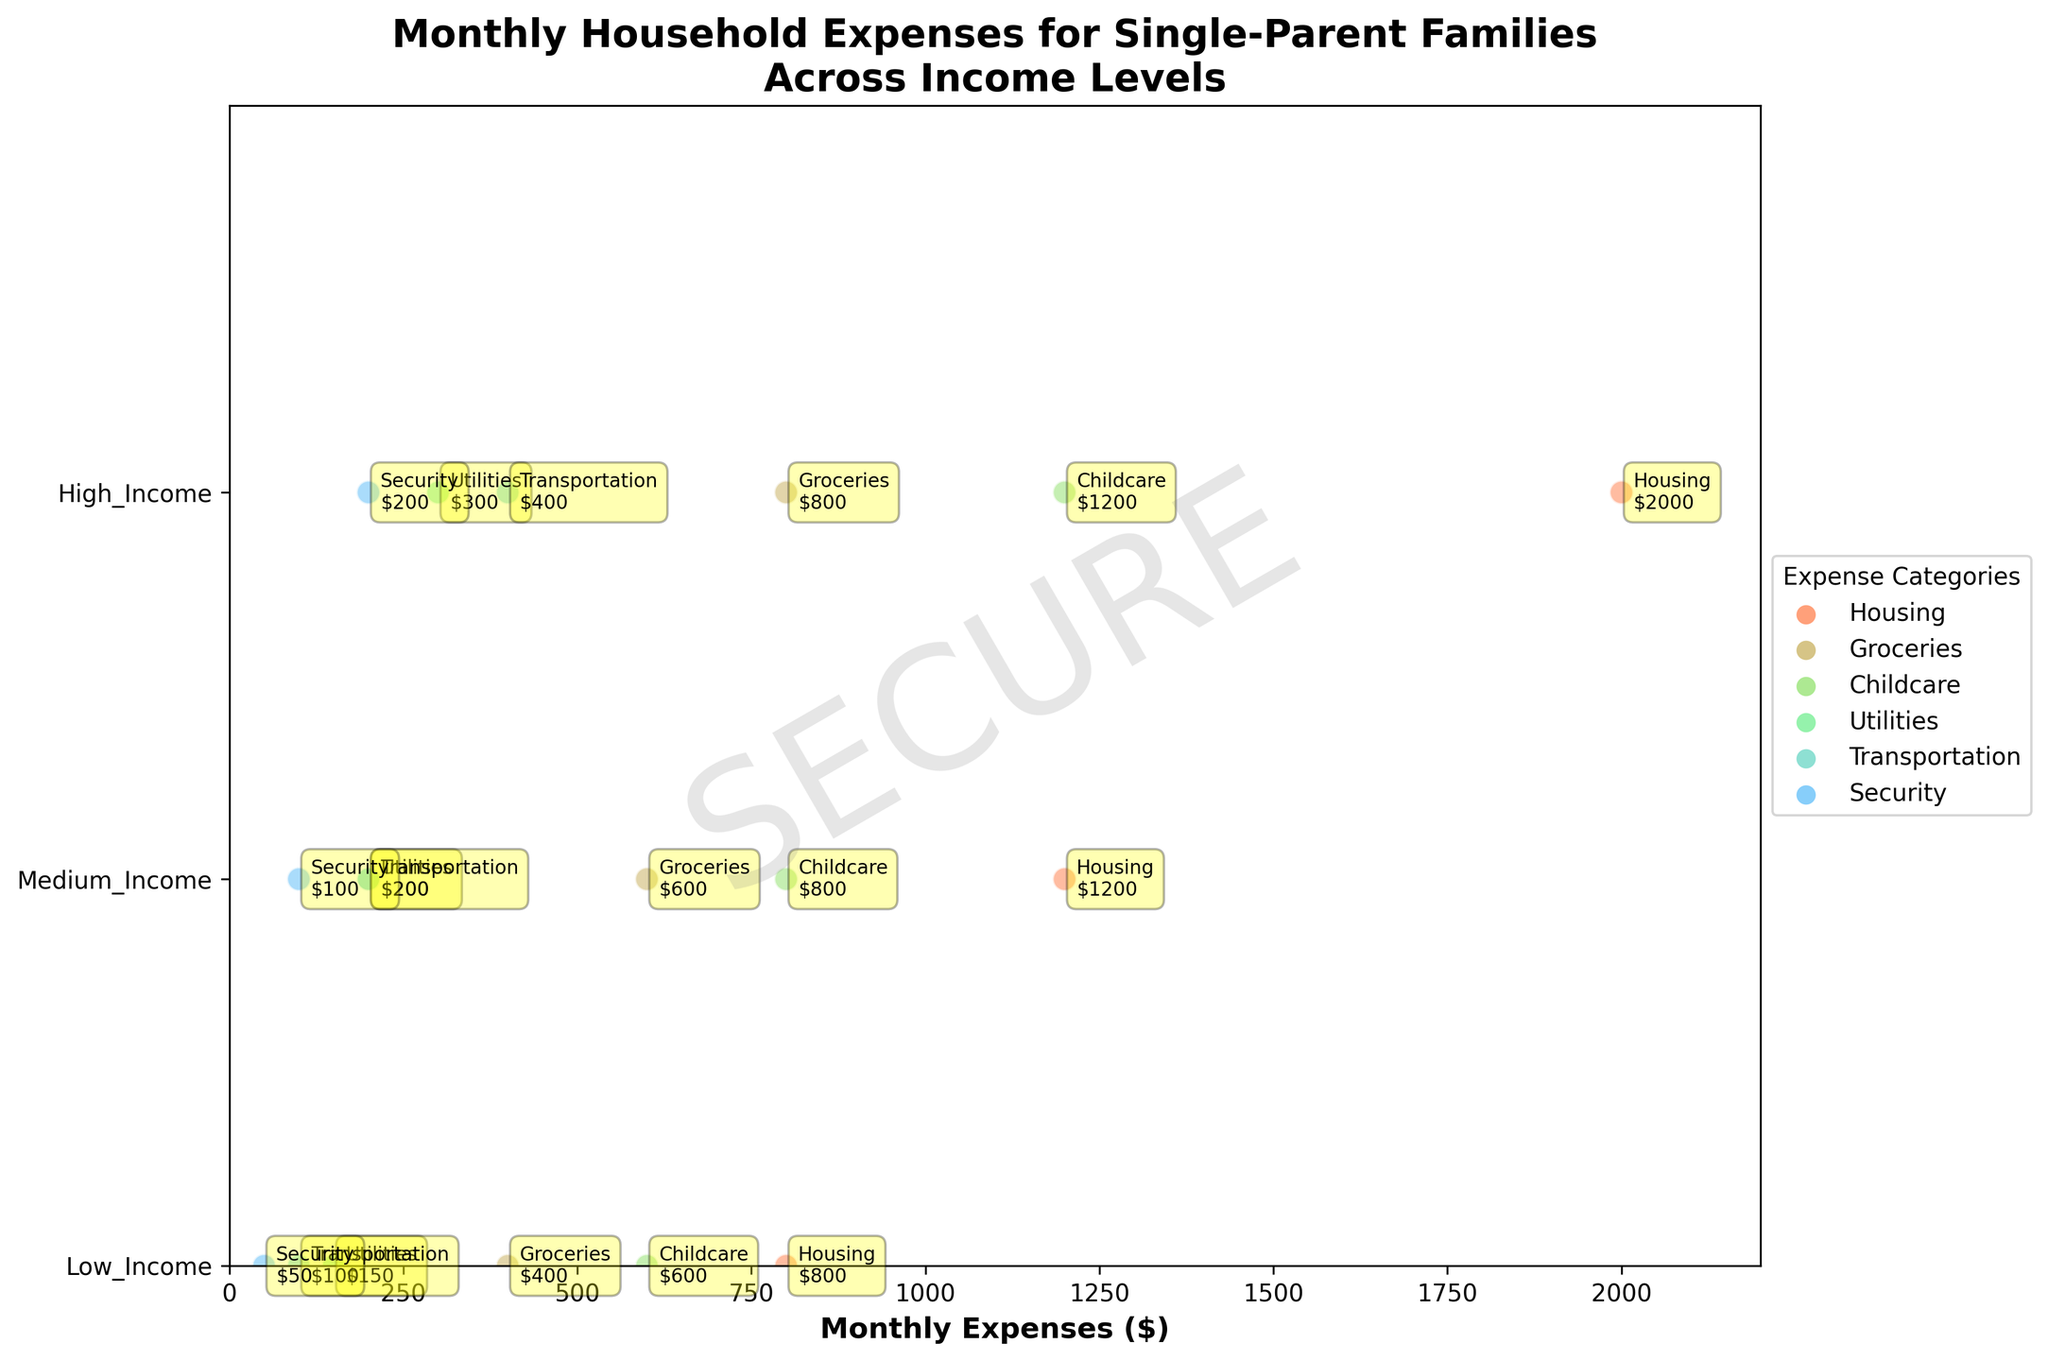Which income level category has the highest housing expense? By looking at the ridgeline plot, we see that the housing expenses are listed for each income level. The "High_Income" category has the highest monthly expense for housing, which is $2000.
Answer: High_Income What is the total monthly expense for Groceries in all income levels? Add the grocery expenses for each income level. From the plot: Low_Income = $400, Medium_Income = $600, High_Income = $800. Summing these: 400 + 600 + 800 = $1800.
Answer: $1800 Compare the Childcare expenses in Low_Income and Medium_Income categories. Which one is higher and by how much? Childcare expense for Low_Income is $600 and for Medium_Income, it is $800. The difference is 800 - 600 = $200, so Medium_Income has a higher expense by $200.
Answer: Medium_Income by $200 Which expense category has the lowest value and what is that value? Looking at each expense category across all income levels, the lowest value is for Security in Low_Income, which is $50.
Answer: Security with $50 Is the Utilities expense more than the Transportation expense in the Medium_Income category? In the Medium_Income category, the Utilities expense is $200 while the Transportation expense is also $200. Therefore, they are equal.
Answer: No, they are equal For High_Income families, what is the sum of the Transportation and Security expenses? From the plot, Transportation expense is $400 and Security expense is $200. Summing these: 400 + 200 = $600.
Answer: $600 Which income level spends the least amount on Transportation? By observing the plot, the transportation expenses are: Low_Income = $100, Medium_Income = $200, High_Income = $400. The least amount is spent by Low_Income.
Answer: Low_Income Which expense category in High_Income families has a total of more than $1000? From the plot, the only expense categories in High_Income that total more than $1000 are Housing ($2000) and Childcare ($1200).
Answer: Housing and Childcare What is the average expense for Security across all income levels? Add up the Security expenses for each income level and divide by the number of levels. Low_Income = $50, Medium_Income = $100, High_Income = $200. Total = 50 + 100 + 200 = $350. Average = 350 / 3 = $116.67.
Answer: $116.67 